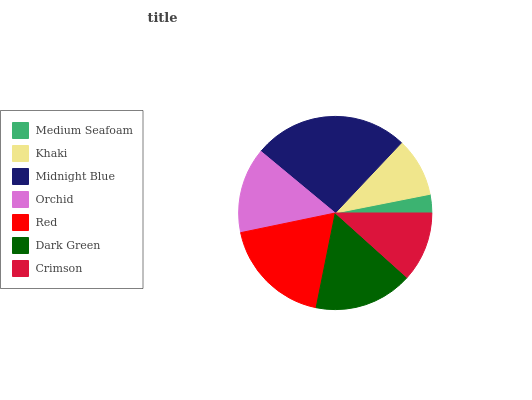Is Medium Seafoam the minimum?
Answer yes or no. Yes. Is Midnight Blue the maximum?
Answer yes or no. Yes. Is Khaki the minimum?
Answer yes or no. No. Is Khaki the maximum?
Answer yes or no. No. Is Khaki greater than Medium Seafoam?
Answer yes or no. Yes. Is Medium Seafoam less than Khaki?
Answer yes or no. Yes. Is Medium Seafoam greater than Khaki?
Answer yes or no. No. Is Khaki less than Medium Seafoam?
Answer yes or no. No. Is Orchid the high median?
Answer yes or no. Yes. Is Orchid the low median?
Answer yes or no. Yes. Is Medium Seafoam the high median?
Answer yes or no. No. Is Khaki the low median?
Answer yes or no. No. 